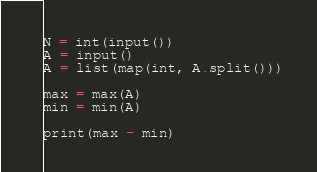Convert code to text. <code><loc_0><loc_0><loc_500><loc_500><_Python_>N = int(input())
A = input()
A = list(map(int, A.split()))

max = max(A)
min = min(A)

print(max - min)
</code> 